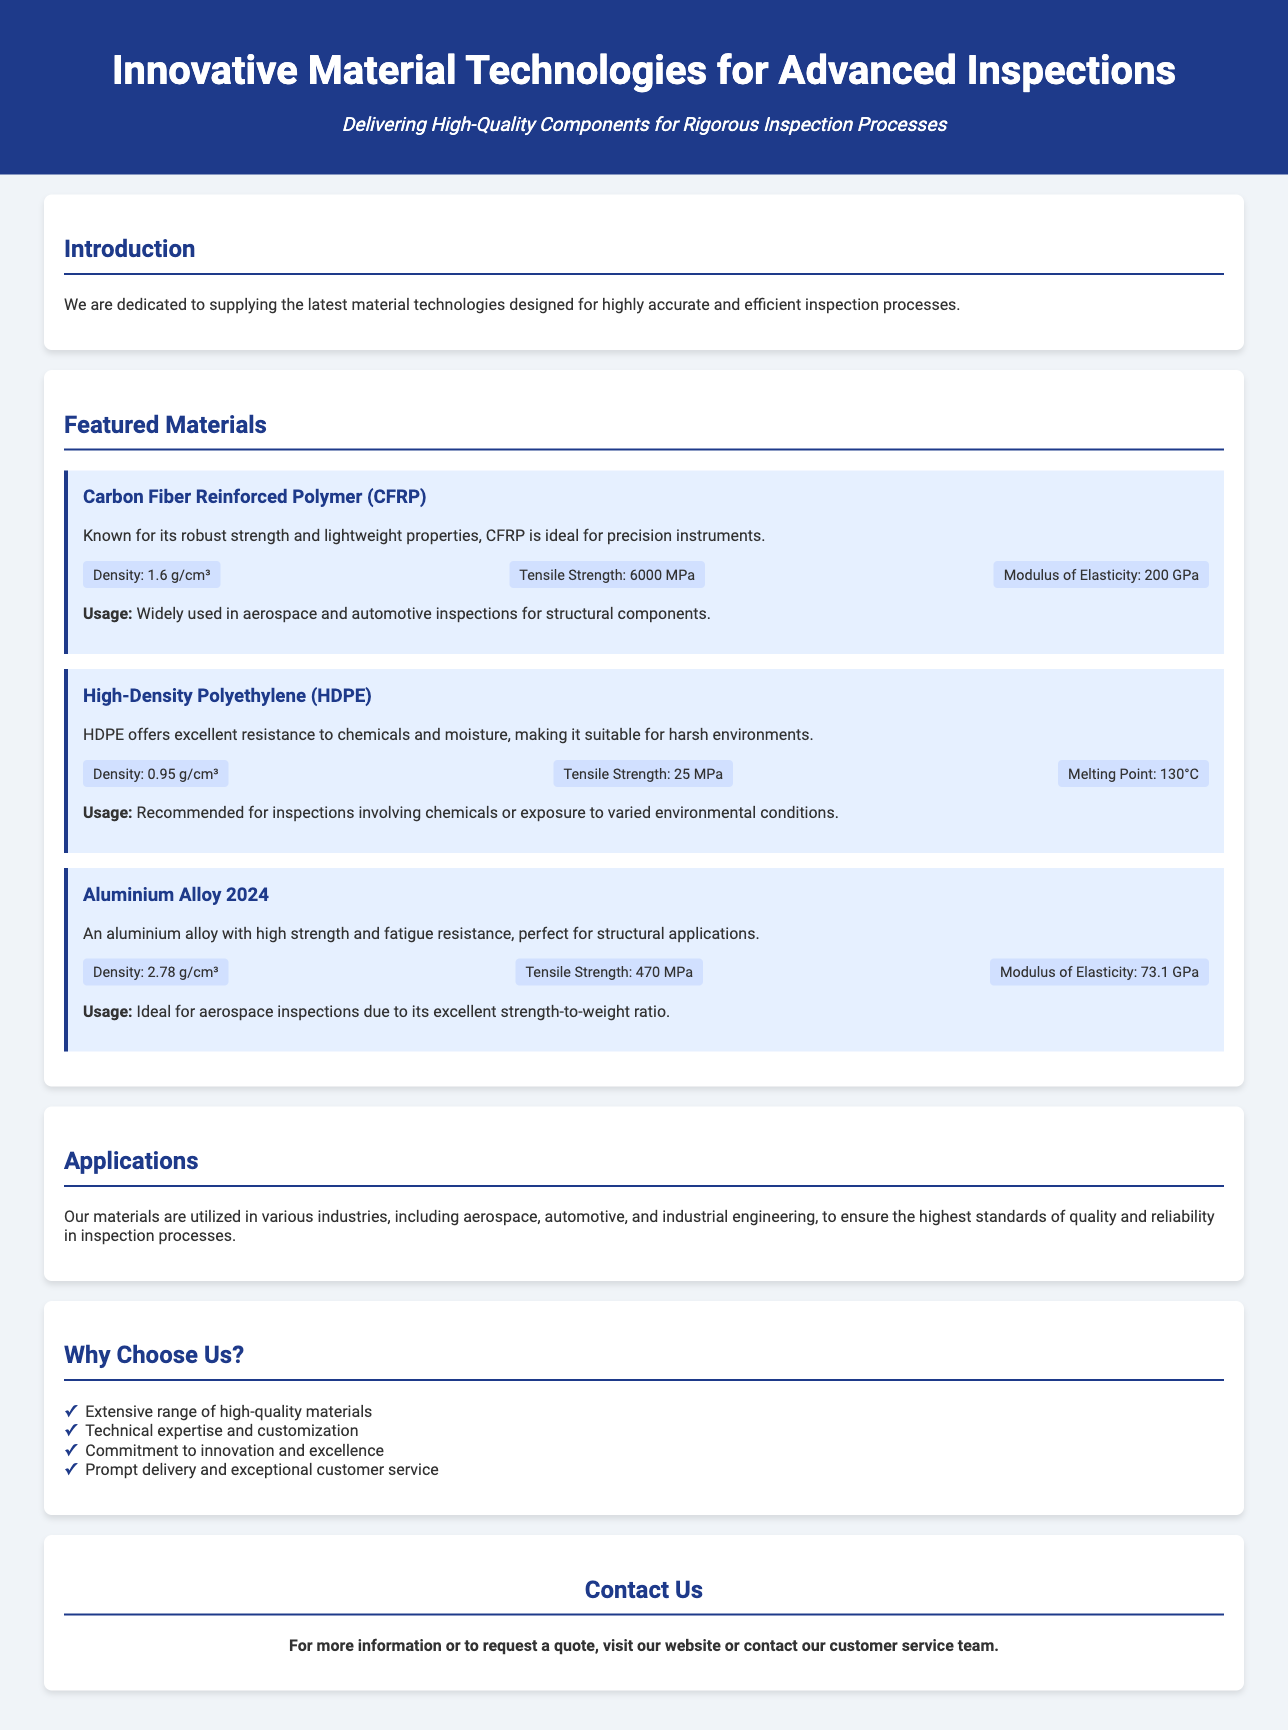what is the title of the document? The title of the document is stated at the top of the flyer.
Answer: Innovative Material Technologies for Advanced Inspections what material is known for its lightweight properties? The document mentions specific materials and their properties. CFRP is highlighted for its lightweight characteristics.
Answer: Carbon Fiber Reinforced Polymer (CFRP) what is the tensile strength of Aluminium Alloy 2024? The tensile strength of Aluminium Alloy 2024 is provided in the specifications section.
Answer: 470 MPa what is the melting point of High-Density Polyethylene? The melting point of HDPE is included among its specifications.
Answer: 130°C which industries utilize the materials supplied? The applications section mentions specific industries that use the materials.
Answer: aerospace, automotive, industrial engineering what is a reason to choose the supplier? The "Why Choose Us?" section lists reasons to select the supplier.
Answer: Extensive range of high-quality materials how many featured materials are listed in the document? The document provides distinct sections for each featured material.
Answer: Three what is the density of Carbon Fiber Reinforced Polymer? The density of CFRP is specified in the document under its specifications.
Answer: 1.6 g/cm³ what does the contact section prompt the reader to do? The instruction in the contact section suggests actions for the reader regarding further engagement.
Answer: Visit our website or contact our customer service team 